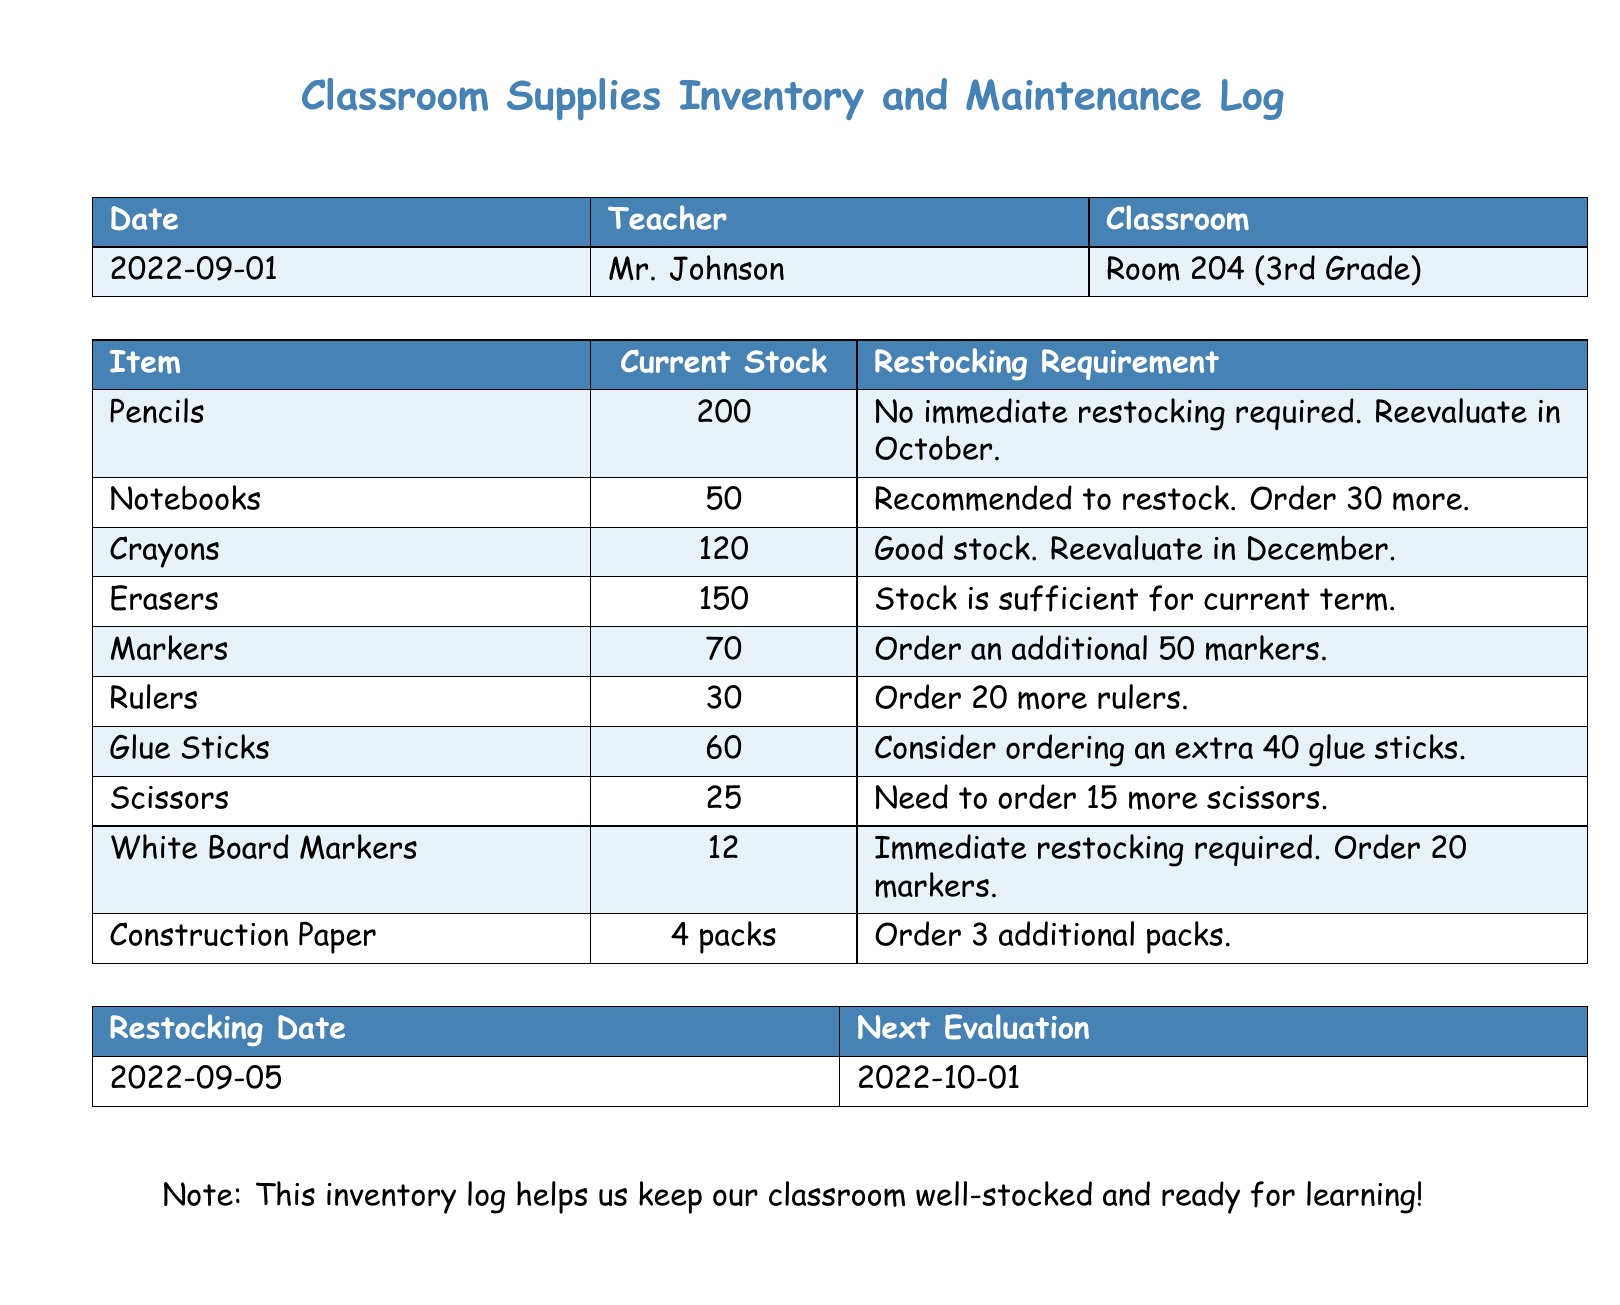What is the date of the inventory log? The date of the inventory log is listed at the top of the document.
Answer: 2022-09-01 Who is the teacher in the log? The teacher's name is provided in the first table of the document.
Answer: Mr. Johnson What is the current stock of markers? The stock of markers is shown in the detailed list of items.
Answer: 70 How many glue sticks are recommended to order? The recommendation for glue sticks is specified in the inventory log.
Answer: 40 When is the next evaluation date? The next evaluation date is mentioned in the final table of the document.
Answer: 2022-10-01 Which item has an immediate restocking requirement? The item requiring immediate restocking can be found in the restocking requirements section.
Answer: White Board Markers What is the total current stock of pencils and erasers combined? The total is calculated by adding the stocks of pencils and erasers in the document.
Answer: 350 What is the recommended action for notebooks? The recommended action for notebooks is indicated in the requirements column.
Answer: Order 30 more What color is used for the header of the inventory table? The color for the header in the inventory table is specified in the document.
Answer: School Blue 